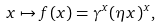Convert formula to latex. <formula><loc_0><loc_0><loc_500><loc_500>x \mapsto f ( x ) = \gamma ^ { x } ( \eta x ) ^ { x } ,</formula> 